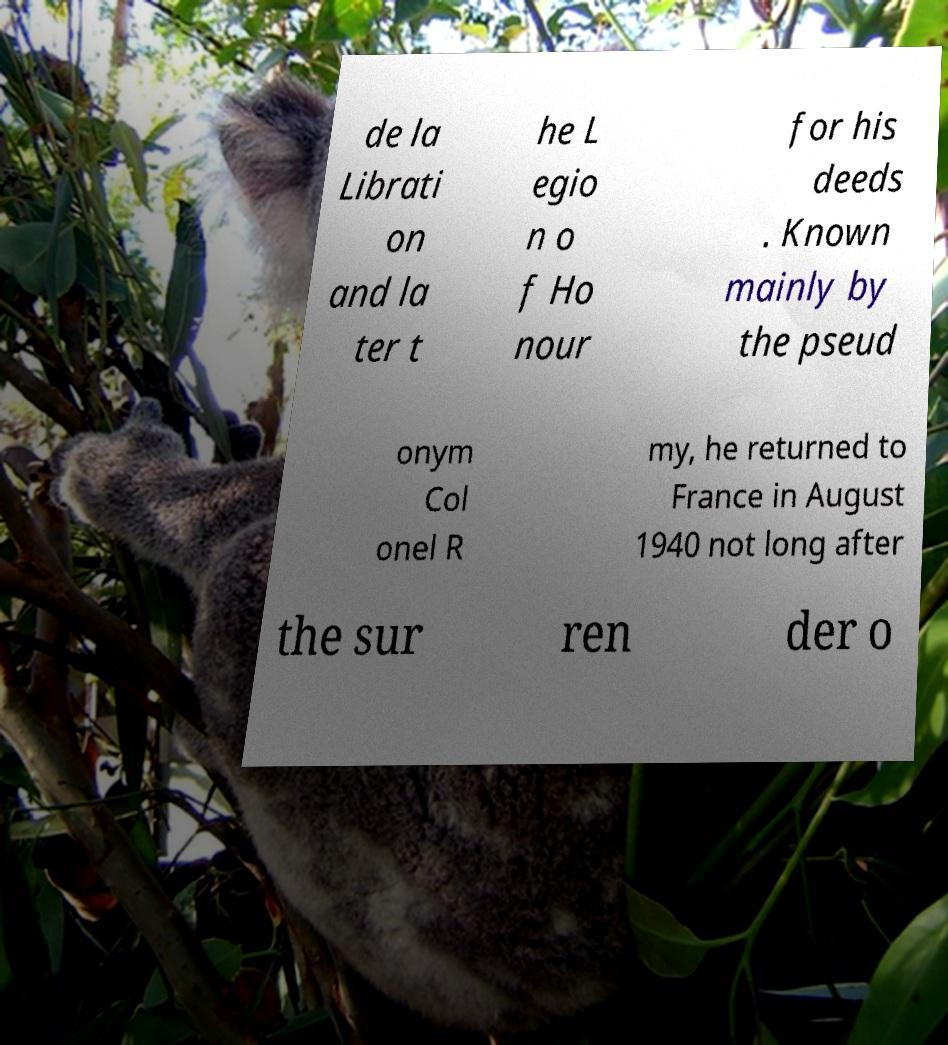For documentation purposes, I need the text within this image transcribed. Could you provide that? de la Librati on and la ter t he L egio n o f Ho nour for his deeds . Known mainly by the pseud onym Col onel R my, he returned to France in August 1940 not long after the sur ren der o 